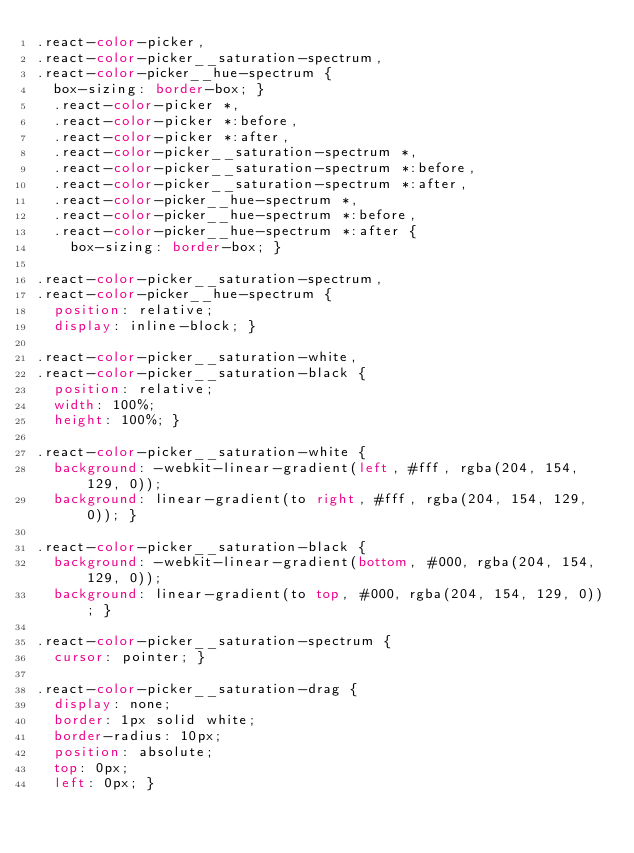Convert code to text. <code><loc_0><loc_0><loc_500><loc_500><_CSS_>.react-color-picker,
.react-color-picker__saturation-spectrum,
.react-color-picker__hue-spectrum {
  box-sizing: border-box; }
  .react-color-picker *,
  .react-color-picker *:before,
  .react-color-picker *:after,
  .react-color-picker__saturation-spectrum *,
  .react-color-picker__saturation-spectrum *:before,
  .react-color-picker__saturation-spectrum *:after,
  .react-color-picker__hue-spectrum *,
  .react-color-picker__hue-spectrum *:before,
  .react-color-picker__hue-spectrum *:after {
    box-sizing: border-box; }

.react-color-picker__saturation-spectrum,
.react-color-picker__hue-spectrum {
  position: relative;
  display: inline-block; }

.react-color-picker__saturation-white,
.react-color-picker__saturation-black {
  position: relative;
  width: 100%;
  height: 100%; }

.react-color-picker__saturation-white {
  background: -webkit-linear-gradient(left, #fff, rgba(204, 154, 129, 0));
  background: linear-gradient(to right, #fff, rgba(204, 154, 129, 0)); }

.react-color-picker__saturation-black {
  background: -webkit-linear-gradient(bottom, #000, rgba(204, 154, 129, 0));
  background: linear-gradient(to top, #000, rgba(204, 154, 129, 0)); }

.react-color-picker__saturation-spectrum {
  cursor: pointer; }

.react-color-picker__saturation-drag {
  display: none;
  border: 1px solid white;
  border-radius: 10px;
  position: absolute;
  top: 0px;
  left: 0px; }</code> 